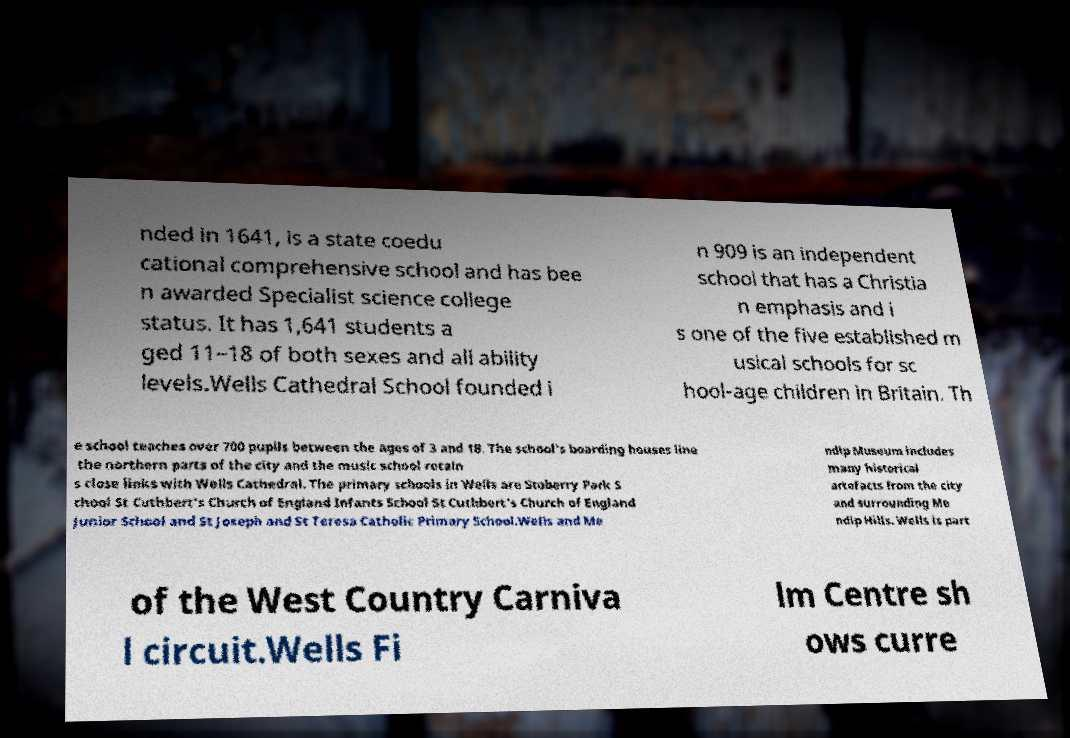Can you accurately transcribe the text from the provided image for me? nded in 1641, is a state coedu cational comprehensive school and has bee n awarded Specialist science college status. It has 1,641 students a ged 11–18 of both sexes and all ability levels.Wells Cathedral School founded i n 909 is an independent school that has a Christia n emphasis and i s one of the five established m usical schools for sc hool-age children in Britain. Th e school teaches over 700 pupils between the ages of 3 and 18. The school's boarding houses line the northern parts of the city and the music school retain s close links with Wells Cathedral. The primary schools in Wells are Stoberry Park S chool St Cuthbert's Church of England Infants School St Cuthbert's Church of England Junior School and St Joseph and St Teresa Catholic Primary School.Wells and Me ndip Museum includes many historical artefacts from the city and surrounding Me ndip Hills. Wells is part of the West Country Carniva l circuit.Wells Fi lm Centre sh ows curre 